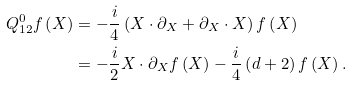<formula> <loc_0><loc_0><loc_500><loc_500>Q _ { 1 2 } ^ { 0 } f \left ( X \right ) & = - \frac { i } { 4 } \left ( X \cdot \partial _ { X } + \partial _ { X } \cdot X \right ) f \left ( X \right ) \\ & = - \frac { i } { 2 } X \cdot \partial _ { X } f \left ( X \right ) - \frac { i } { 4 } \left ( d + 2 \right ) f \left ( X \right ) .</formula> 